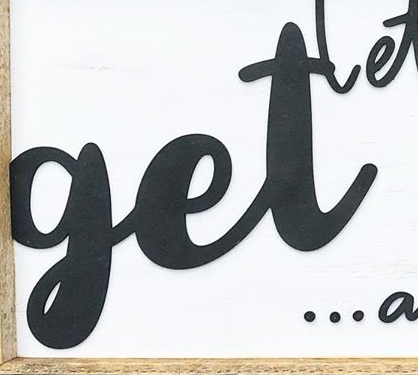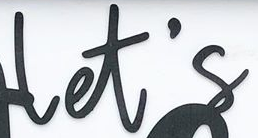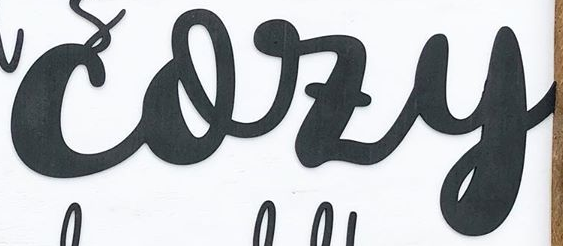What words are shown in these images in order, separated by a semicolon? get; let's; cozy 